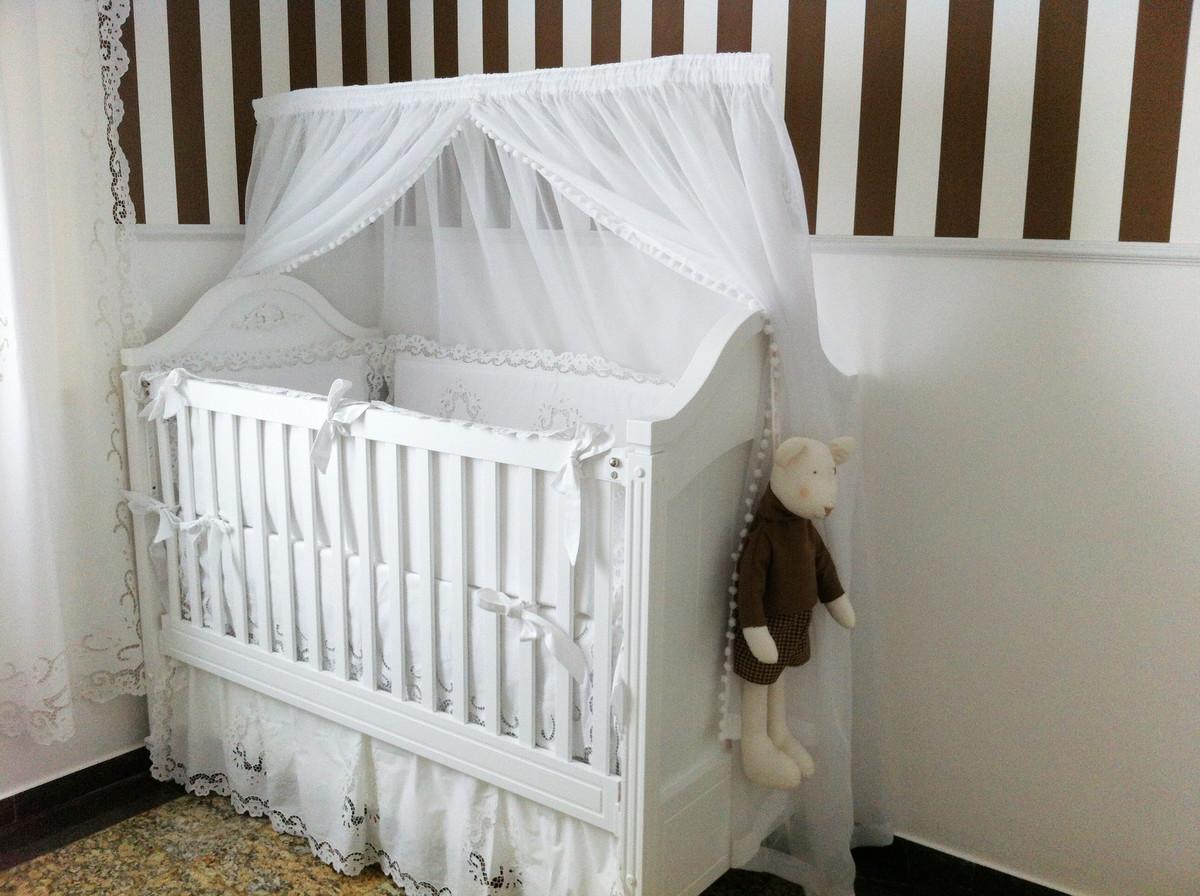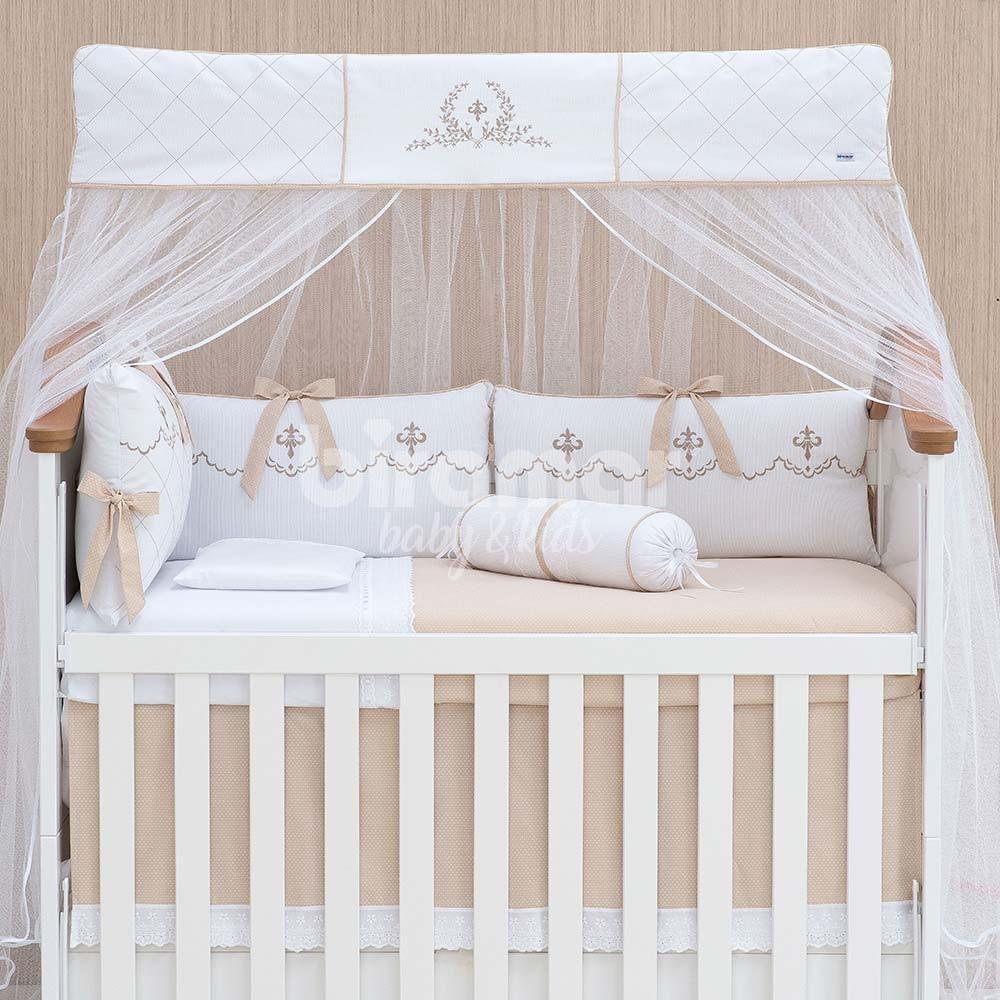The first image is the image on the left, the second image is the image on the right. Examine the images to the left and right. Is the description "A tented net covers a sleeping area with a stuffed animal in the image on the right." accurate? Answer yes or no. No. 